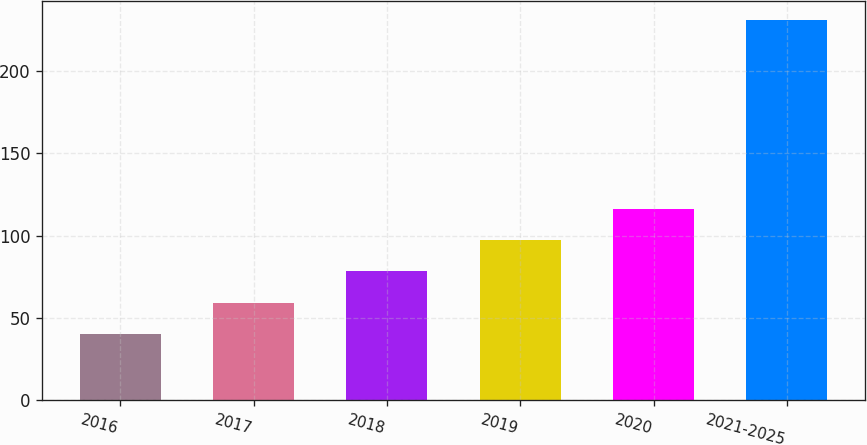Convert chart to OTSL. <chart><loc_0><loc_0><loc_500><loc_500><bar_chart><fcel>2016<fcel>2017<fcel>2018<fcel>2019<fcel>2020<fcel>2021-2025<nl><fcel>40.3<fcel>59.36<fcel>78.42<fcel>97.48<fcel>116.54<fcel>230.9<nl></chart> 